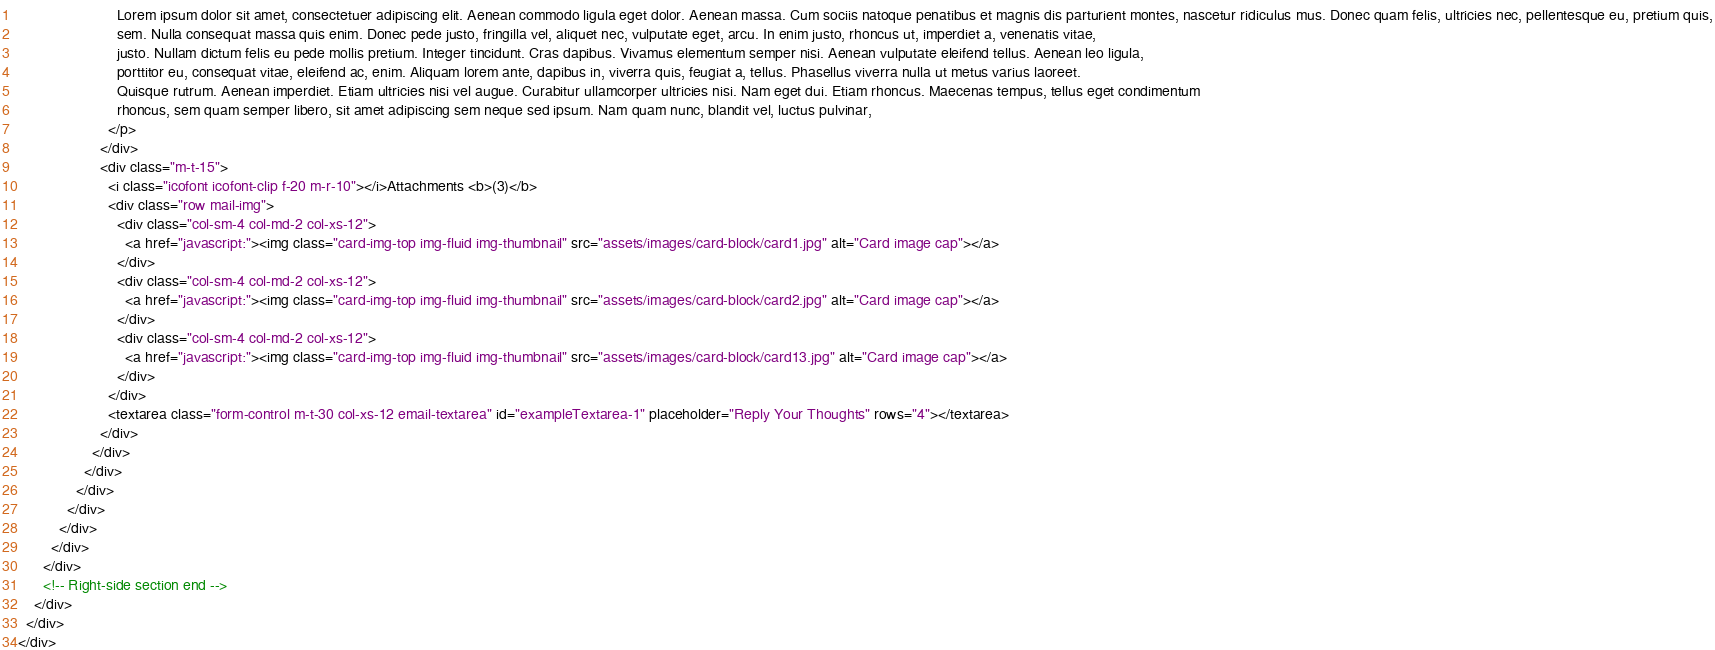Convert code to text. <code><loc_0><loc_0><loc_500><loc_500><_HTML_>                        Lorem ipsum dolor sit amet, consectetuer adipiscing elit. Aenean commodo ligula eget dolor. Aenean massa. Cum sociis natoque penatibus et magnis dis parturient montes, nascetur ridiculus mus. Donec quam felis, ultricies nec, pellentesque eu, pretium quis,
                        sem. Nulla consequat massa quis enim. Donec pede justo, fringilla vel, aliquet nec, vulputate eget, arcu. In enim justo, rhoncus ut, imperdiet a, venenatis vitae,
                        justo. Nullam dictum felis eu pede mollis pretium. Integer tincidunt. Cras dapibus. Vivamus elementum semper nisi. Aenean vulputate eleifend tellus. Aenean leo ligula,
                        porttitor eu, consequat vitae, eleifend ac, enim. Aliquam lorem ante, dapibus in, viverra quis, feugiat a, tellus. Phasellus viverra nulla ut metus varius laoreet.
                        Quisque rutrum. Aenean imperdiet. Etiam ultricies nisi vel augue. Curabitur ullamcorper ultricies nisi. Nam eget dui. Etiam rhoncus. Maecenas tempus, tellus eget condimentum
                        rhoncus, sem quam semper libero, sit amet adipiscing sem neque sed ipsum. Nam quam nunc, blandit vel, luctus pulvinar,
                      </p>
                    </div>
                    <div class="m-t-15">
                      <i class="icofont icofont-clip f-20 m-r-10"></i>Attachments <b>(3)</b>
                      <div class="row mail-img">
                        <div class="col-sm-4 col-md-2 col-xs-12">
                          <a href="javascript:"><img class="card-img-top img-fluid img-thumbnail" src="assets/images/card-block/card1.jpg" alt="Card image cap"></a>
                        </div>
                        <div class="col-sm-4 col-md-2 col-xs-12">
                          <a href="javascript:"><img class="card-img-top img-fluid img-thumbnail" src="assets/images/card-block/card2.jpg" alt="Card image cap"></a>
                        </div>
                        <div class="col-sm-4 col-md-2 col-xs-12">
                          <a href="javascript:"><img class="card-img-top img-fluid img-thumbnail" src="assets/images/card-block/card13.jpg" alt="Card image cap"></a>
                        </div>
                      </div>
                      <textarea class="form-control m-t-30 col-xs-12 email-textarea" id="exampleTextarea-1" placeholder="Reply Your Thoughts" rows="4"></textarea>
                    </div>
                  </div>
                </div>
              </div>
            </div>
          </div>
        </div>
      </div>
      <!-- Right-side section end -->
    </div>
  </div>
</div>
</code> 